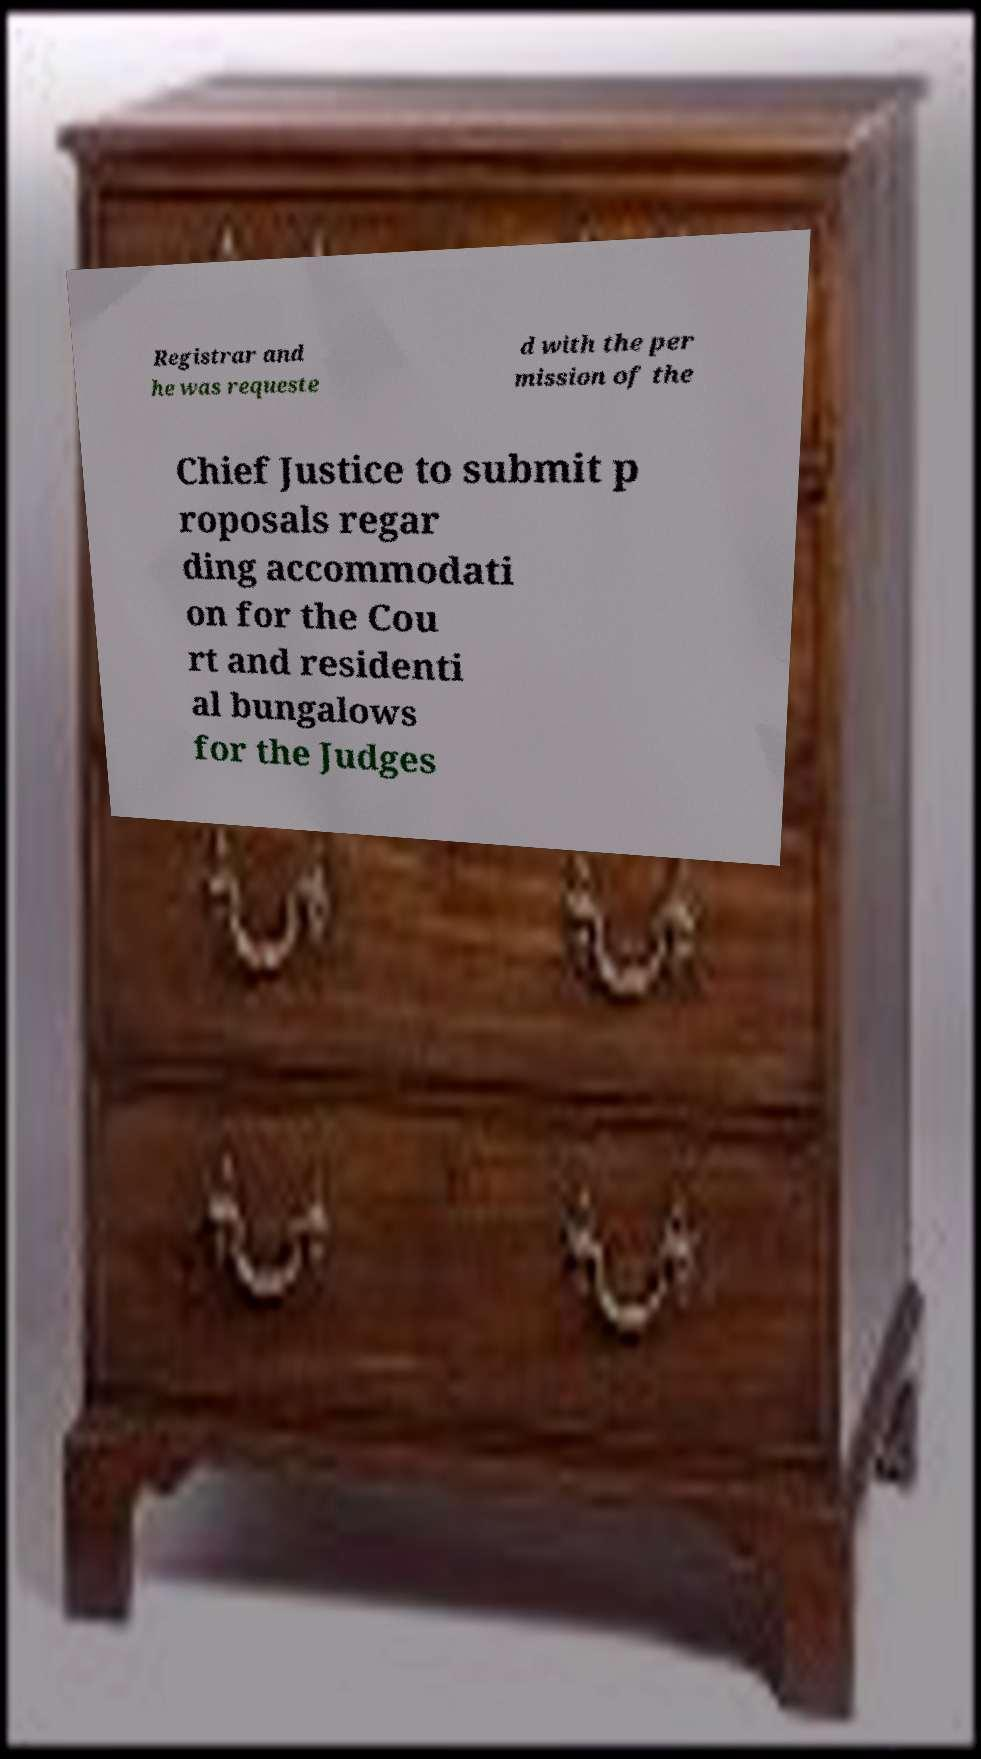Can you read and provide the text displayed in the image?This photo seems to have some interesting text. Can you extract and type it out for me? Registrar and he was requeste d with the per mission of the Chief Justice to submit p roposals regar ding accommodati on for the Cou rt and residenti al bungalows for the Judges 